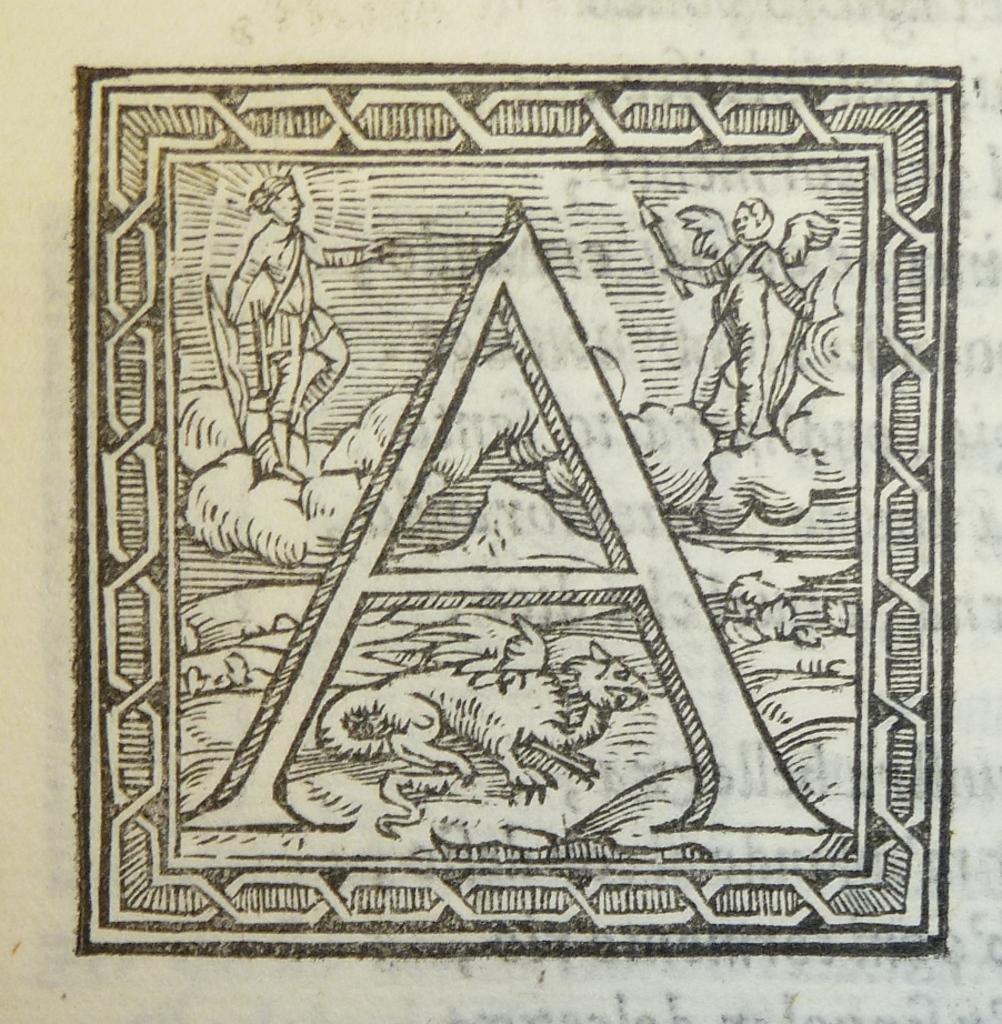In one or two sentences, can you explain what this image depicts? This is a picture of a sketch and its not clear. In this picture we can see the people, an animal. 